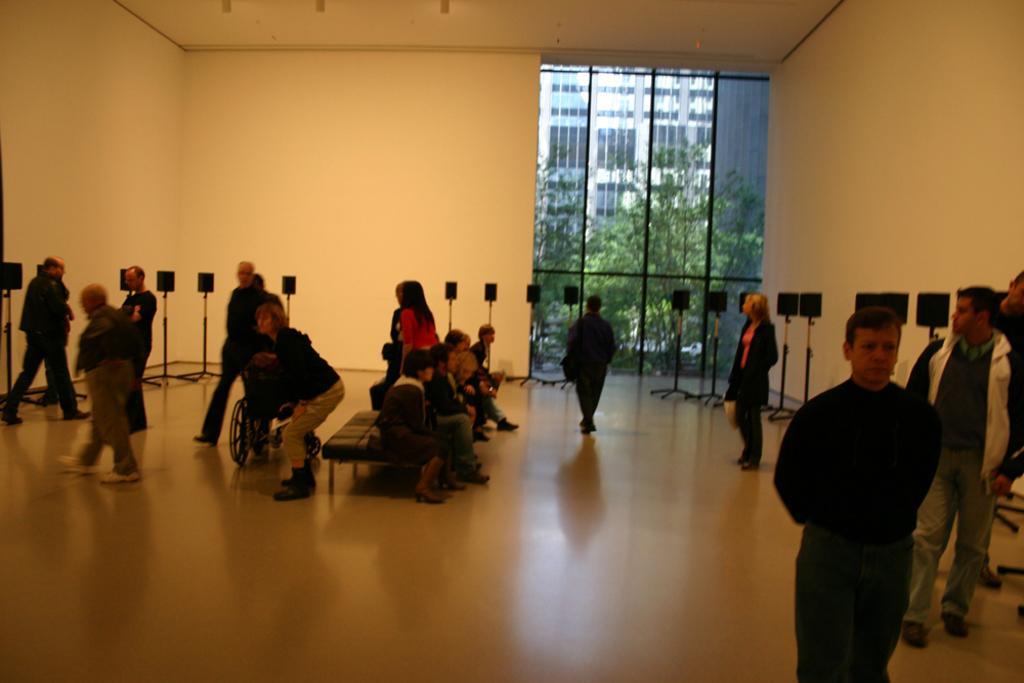In one or two sentences, can you explain what this image depicts? In this picture there are people in the image, some are sitting and some are walking in the image, there is a big glass window in the background area of the image, there are trees outside the window. 